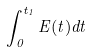Convert formula to latex. <formula><loc_0><loc_0><loc_500><loc_500>\int _ { 0 } ^ { t _ { 1 } } E ( t ) d t</formula> 